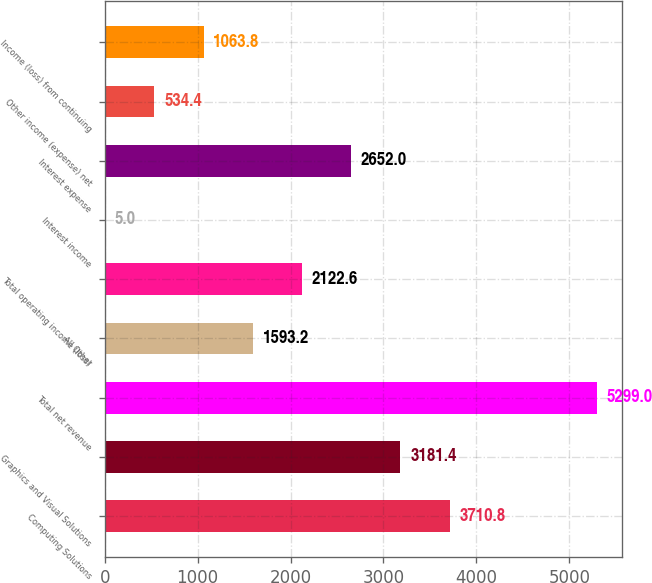<chart> <loc_0><loc_0><loc_500><loc_500><bar_chart><fcel>Computing Solutions<fcel>Graphics and Visual Solutions<fcel>Total net revenue<fcel>All Other<fcel>Total operating income (loss)<fcel>Interest income<fcel>Interest expense<fcel>Other income (expense) net<fcel>Income (loss) from continuing<nl><fcel>3710.8<fcel>3181.4<fcel>5299<fcel>1593.2<fcel>2122.6<fcel>5<fcel>2652<fcel>534.4<fcel>1063.8<nl></chart> 